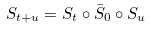<formula> <loc_0><loc_0><loc_500><loc_500>S _ { t + u } = S _ { t } \circ \bar { S } _ { 0 } \circ S _ { u }</formula> 